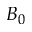<formula> <loc_0><loc_0><loc_500><loc_500>B _ { 0 }</formula> 